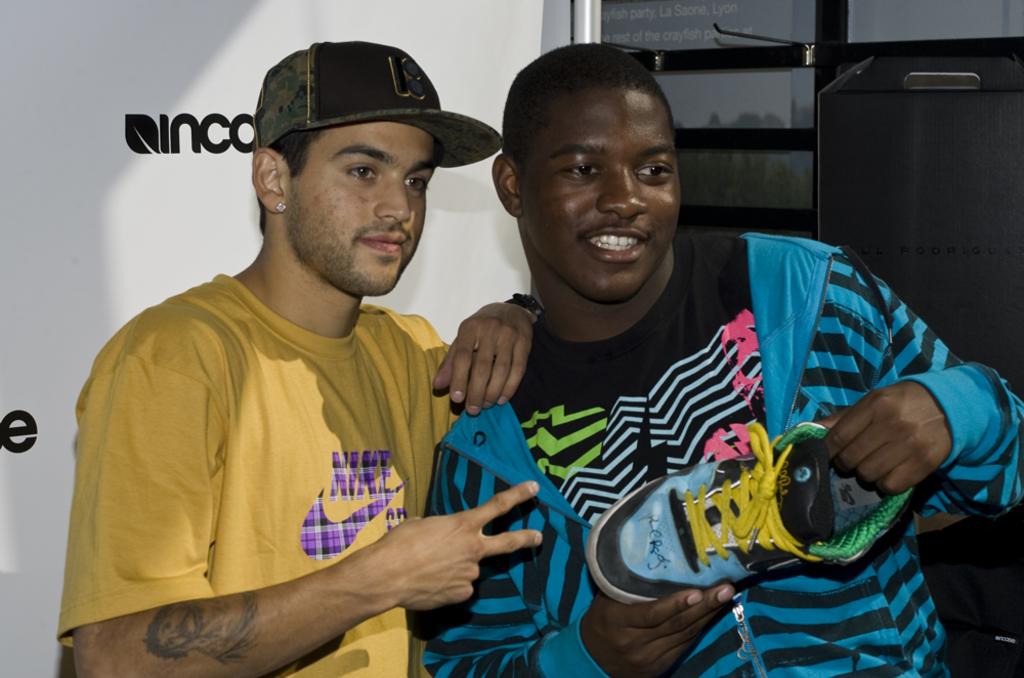What brand is on the back white wall?
Provide a succinct answer. Inco. 